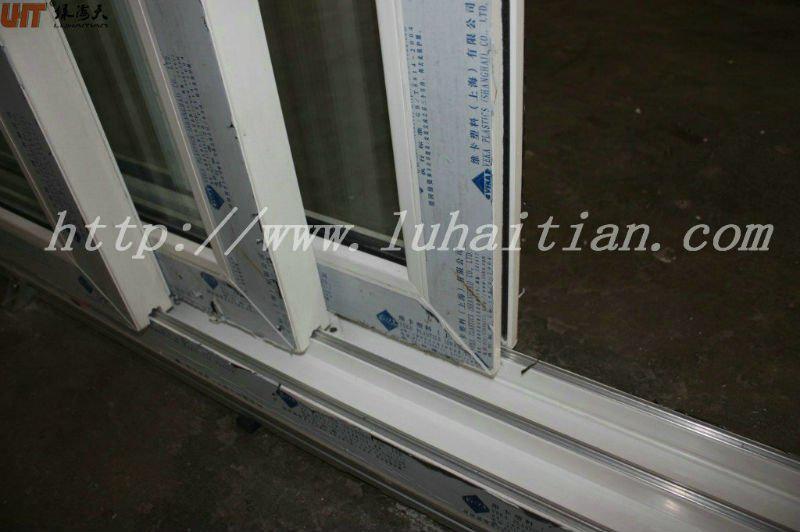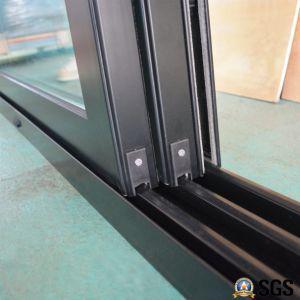The first image is the image on the left, the second image is the image on the right. Considering the images on both sides, is "The metal framed door in the image on the right is opened just a bit." valid? Answer yes or no. Yes. The first image is the image on the left, the second image is the image on the right. Assess this claim about the two images: "An image shows tracks and three sliding glass doors with dark frames.". Correct or not? Answer yes or no. Yes. 